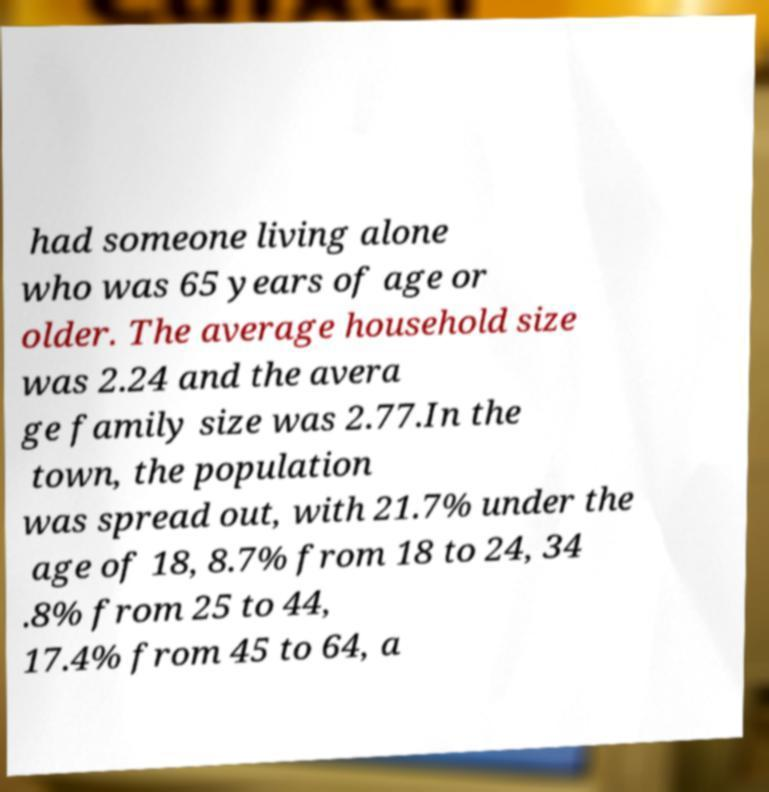I need the written content from this picture converted into text. Can you do that? had someone living alone who was 65 years of age or older. The average household size was 2.24 and the avera ge family size was 2.77.In the town, the population was spread out, with 21.7% under the age of 18, 8.7% from 18 to 24, 34 .8% from 25 to 44, 17.4% from 45 to 64, a 